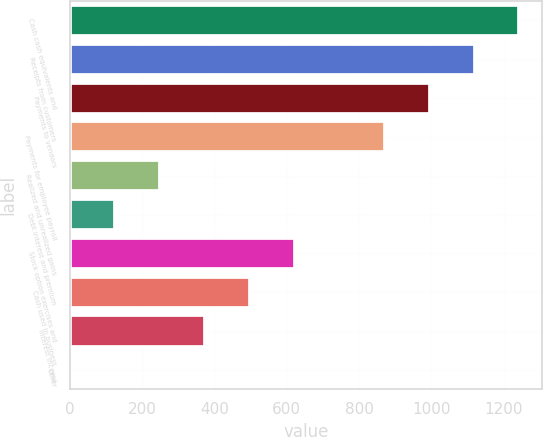Convert chart to OTSL. <chart><loc_0><loc_0><loc_500><loc_500><bar_chart><fcel>Cash cash equivalents and<fcel>Receipts from customers<fcel>Payments to vendors<fcel>Payments for employee payroll<fcel>Realized and unrealized gains<fcel>Debt interest and premium<fcel>Stock option exercises and<fcel>Cash used in business<fcel>Interest income<fcel>Other<nl><fcel>1243.4<fcel>1119.08<fcel>994.76<fcel>870.44<fcel>248.84<fcel>124.52<fcel>621.8<fcel>497.48<fcel>373.16<fcel>0.2<nl></chart> 